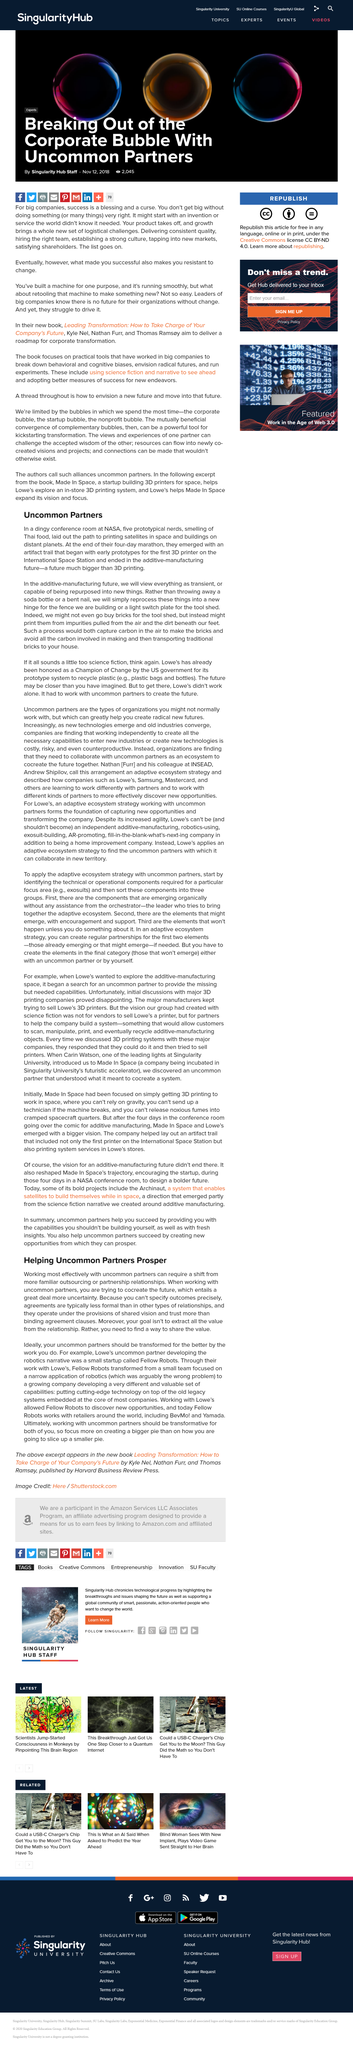Point out several critical features in this image. The early prototypes of 3D printing technology developed by Made In Space were the first 3D printer to be launched and operated on the International Space Station. These prototypes were instrumental in the success of the company's mission to make 3D printing a viable technology for use in space. It is common for relationships with uncommon partners to have less formal arrangements because it is difficult to predict precise outcomes. My goal in a relationship with uncommon partners is to find a way to share the value that we both bring, in order to create a harmonious and mutually beneficial partnership. The article was posted on November 12, 2018, as declared in the text. I am striving to co-create the future, along with my uncommon partners, by working towards a common goal. 